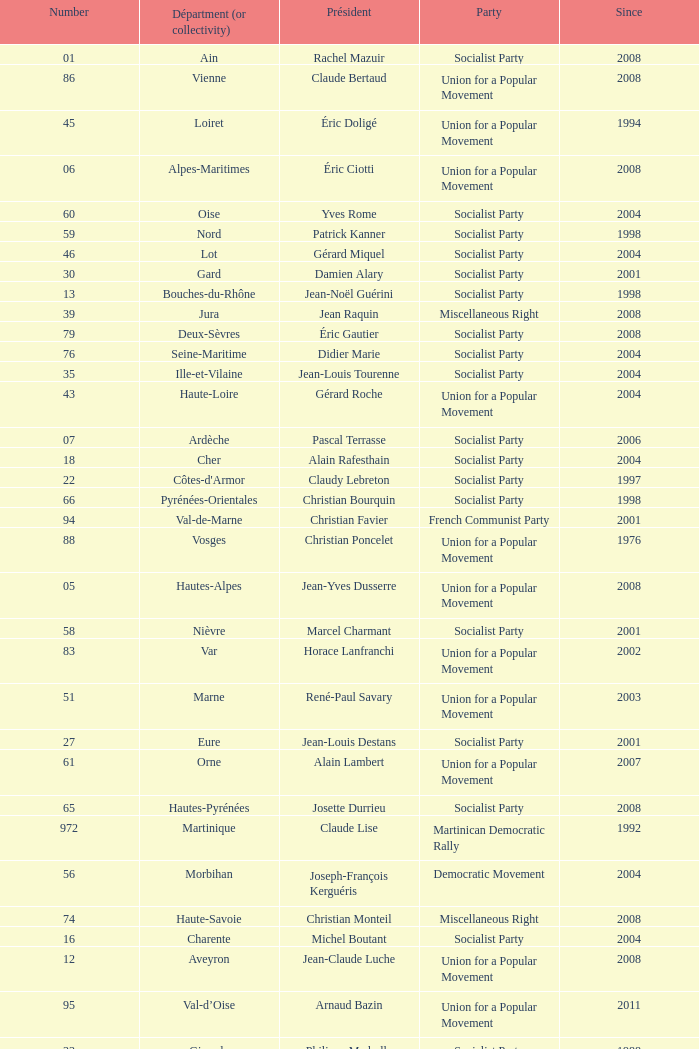Who is the president from the Union for a Popular Movement party that represents the Hautes-Alpes department? Jean-Yves Dusserre. Could you parse the entire table? {'header': ['Number', 'Départment (or collectivity)', 'Président', 'Party', 'Since'], 'rows': [['01', 'Ain', 'Rachel Mazuir', 'Socialist Party', '2008'], ['86', 'Vienne', 'Claude Bertaud', 'Union for a Popular Movement', '2008'], ['45', 'Loiret', 'Éric Doligé', 'Union for a Popular Movement', '1994'], ['06', 'Alpes-Maritimes', 'Éric Ciotti', 'Union for a Popular Movement', '2008'], ['60', 'Oise', 'Yves Rome', 'Socialist Party', '2004'], ['59', 'Nord', 'Patrick Kanner', 'Socialist Party', '1998'], ['46', 'Lot', 'Gérard Miquel', 'Socialist Party', '2004'], ['30', 'Gard', 'Damien Alary', 'Socialist Party', '2001'], ['13', 'Bouches-du-Rhône', 'Jean-Noël Guérini', 'Socialist Party', '1998'], ['39', 'Jura', 'Jean Raquin', 'Miscellaneous Right', '2008'], ['79', 'Deux-Sèvres', 'Éric Gautier', 'Socialist Party', '2008'], ['76', 'Seine-Maritime', 'Didier Marie', 'Socialist Party', '2004'], ['35', 'Ille-et-Vilaine', 'Jean-Louis Tourenne', 'Socialist Party', '2004'], ['43', 'Haute-Loire', 'Gérard Roche', 'Union for a Popular Movement', '2004'], ['07', 'Ardèche', 'Pascal Terrasse', 'Socialist Party', '2006'], ['18', 'Cher', 'Alain Rafesthain', 'Socialist Party', '2004'], ['22', "Côtes-d'Armor", 'Claudy Lebreton', 'Socialist Party', '1997'], ['66', 'Pyrénées-Orientales', 'Christian Bourquin', 'Socialist Party', '1998'], ['94', 'Val-de-Marne', 'Christian Favier', 'French Communist Party', '2001'], ['88', 'Vosges', 'Christian Poncelet', 'Union for a Popular Movement', '1976'], ['05', 'Hautes-Alpes', 'Jean-Yves Dusserre', 'Union for a Popular Movement', '2008'], ['58', 'Nièvre', 'Marcel Charmant', 'Socialist Party', '2001'], ['83', 'Var', 'Horace Lanfranchi', 'Union for a Popular Movement', '2002'], ['51', 'Marne', 'René-Paul Savary', 'Union for a Popular Movement', '2003'], ['27', 'Eure', 'Jean-Louis Destans', 'Socialist Party', '2001'], ['61', 'Orne', 'Alain Lambert', 'Union for a Popular Movement', '2007'], ['65', 'Hautes-Pyrénées', 'Josette Durrieu', 'Socialist Party', '2008'], ['972', 'Martinique', 'Claude Lise', 'Martinican Democratic Rally', '1992'], ['56', 'Morbihan', 'Joseph-François Kerguéris', 'Democratic Movement', '2004'], ['74', 'Haute-Savoie', 'Christian Monteil', 'Miscellaneous Right', '2008'], ['16', 'Charente', 'Michel Boutant', 'Socialist Party', '2004'], ['12', 'Aveyron', 'Jean-Claude Luche', 'Union for a Popular Movement', '2008'], ['95', 'Val-d’Oise', 'Arnaud Bazin', 'Union for a Popular Movement', '2011'], ['33', 'Gironde', 'Philippe Madrelle', 'Socialist Party', '1988'], ['89', 'Yonne', 'Jean-Marie Rolland', 'Union for a Popular Movement', '2008'], ['02', 'Aisne', 'Yves Daudigny', 'Socialist Party', '2001'], ['971', 'Guadeloupe', 'Jacques Gillot', 'United Guadeloupe, Socialism and Realities', '2001'], ['81', 'Tarn', 'Thierry Carcenac', 'Socialist Party', '1991'], ['47', 'Lot-et-Garonne', 'Pierre Camani', 'Socialist Party', '2008'], ['14', 'Calvados', "Anne d'Ornano", 'Miscellaneous Right', '1991'], ['25', 'Doubs', 'Claude Jeannerot', 'Socialist Party', '2004'], ['19', 'Corrèze', 'François Hollande', 'Socialist Party', '2008'], ['23', 'Creuse', 'Jean-Jacques Lozach', 'Socialist Party', '2001'], ['08', 'Ardennes', 'Benoît Huré', 'Union for a Popular Movement', '2004'], ['11', 'Aude', 'Marcel Rainaud', 'Socialist Party', '1998'], ['17', 'Charente-Maritime', 'Dominique Bussereau', 'Union for a Popular Movement', '2008'], ['52', 'Haute-Marne', 'Bruno Sido', 'Union for a Popular Movement', '1998'], ['09', 'Ariège', 'Augustin Bonrepaux', 'Socialist Party', '2001'], ['80', 'Somme', 'Christian Manable', 'Socialist Party', '2008'], ['48', 'Lozère', 'Jean-Paul Pourquier', 'Union for a Popular Movement', '2004'], ['37', 'Indre-et-Loire', 'Claude Roiron', 'Socialist Party', '2008'], ['71', 'Saône-et-Loire', 'Arnaud Montebourg', 'Socialist Party', '2008'], ['69', 'Rhône', 'Michel Mercier', 'Miscellaneous Centre', '1990'], ['53', 'Mayenne', 'Jean Arthuis', 'Miscellaneous Centre', '1992'], ['34', 'Hérault', 'André Vezinhet', 'Socialist Party', '1998'], ['21', "Côte-d'Or", 'François Sauvadet', 'New Centre', '2008'], ['87', 'Haute-Vienne', 'Marie-Françoise Pérol-Dumont', 'Socialist Party', '2004'], ['57', 'Moselle', 'Philippe Leroy', 'Union for a Popular Movement', '1992'], ['44', 'Loire-Atlantique', 'Patrick Mareschal', 'Socialist Party', '2004'], ['49', 'Maine-et-Loire', 'Christophe Béchu', 'Union for a Popular Movement', '2004'], ['40', 'Landes', 'Henri Emmanuelli', 'Socialist Party', '1982'], ['70', 'Haute-Saône', 'Yves Krattinger', 'Socialist Party', '2002'], ['55', 'Meuse', 'Christian Namy', 'Miscellaneous Right', '2004'], ['68', 'Haut-Rhin', 'Charles Buttner', 'Union for a Popular Movement', '2004'], ['28', 'Eure-et-Loir', 'Albéric de Montgolfier', 'Union for a Popular Movement', '2001'], ['92', 'Hauts-de-Seine', 'Patrick Devedjian', 'Union for a Popular Movement', '2007'], ['62', 'Pas-de-Calais', 'Dominique Dupilet', 'Socialist Party', '2004'], ['67', 'Bas-Rhin', 'Guy-Dominique Kennel', 'Union for a Popular Movement', '2008'], ['975', 'Saint-Pierre-et-Miquelon (overseas collect.)', 'Stéphane Artano', 'Archipelago Tomorrow', '2006'], ['85', 'Vendée', 'Philippe de Villiers', 'Movement for France', '1988'], ['38', 'Isère', 'André Vallini', 'Socialist Party', '2001'], ['90', 'Territoire de Belfort', 'Yves Ackermann', 'Socialist Party', '2004'], ['03', 'Allier', 'Jean-Paul Dufregne', 'French Communist Party', '2008'], ['84', 'Vaucluse', 'Claude Haut', 'Socialist Party', '2001'], ['54', 'Meurthe-et-Moselle', 'Michel Dinet', 'Socialist Party', '1998'], ['36', 'Indre', 'Louis Pinton', 'Union for a Popular Movement', '1998'], ['26', 'Drôme', 'Didier Guillaume', 'Socialist Party', '2004'], ['77', 'Seine-et-Marne', 'Vincent Eblé', 'Socialist Party', '2004'], ['976', 'Mayotte (overseas collect.)', 'Ahmed Attoumani Douchina', 'Union for a Popular Movement', '2008'], ['2A', 'Corse-du-Sud', 'Jean-Jacques Panunzi', 'Union for a Popular Movement', '2006'], ['50', 'Manche', 'Jean-François Le Grand', 'Union for a Popular Movement', '1998'], ['2B', 'Haute-Corse', 'Joseph Castelli', 'Left Radical Party', '2010'], ['32', 'Gers', 'Philippe Martin', 'Socialist Party', '1998'], ['24', 'Dordogne', 'Bernard Cazeau', 'Socialist Party', '1994'], ['15', 'Cantal', 'Vincent Descœur', 'Union for a Popular Movement', '2001'], ['78', 'Yvelines', 'Pierre Bédier', 'Union for a Popular Movement', '2005'], ['72', 'Sarthe', 'Roland du Luart', 'Union for a Popular Movement', '1998'], ['91', 'Essonne', 'Michel Berson', 'Socialist Party', '1998'], ['64', 'Pyrénées-Atlantiques', 'Jean Castaings', 'Union for a Popular Movement', '2008'], ['75', 'Paris', 'Bertrand Delanoë', 'Socialist Party', '2001'], ['63', 'Puy-de-Dôme', 'Jean-Yves Gouttebel', 'Socialist Party', '2004'], ['31', 'Haute-Garonne', 'Pierre Izard', 'Socialist Party', '1988'], ['973', 'Guyane', 'Alain Tien-Liong', 'Miscellaneous Left', '2008'], ['82', 'Tarn-et-Garonne', 'Jean-Michel Baylet', 'Left Radical Party', '1986'], ['42', 'Loire', 'Bernard Bonne', 'Union for a Popular Movement', '2008'], ['41', 'Loir-et-Cher', 'Maurice Leroy', 'New Centre', '2004'], ['93', 'Seine-Saint-Denis', 'Claude Bartolone', 'Socialist Party', '2008'], ['10', 'Aube', 'Philippe Adnot', 'Liberal and Moderate Movement', '1990'], ['974', 'Réunion', 'Nassimah Dindar', 'Union for a Popular Movement', '2004'], ['04', 'Alpes-de-Haute-Provence', 'Jean-Louis Bianco', 'Socialist Party', '1998'], ['29', 'Finistère', 'Pierre Maille', 'Socialist Party', '1998'], ['73', 'Savoie', 'Hervé Gaymard', 'Union for a Popular Movement', '2008']]} 